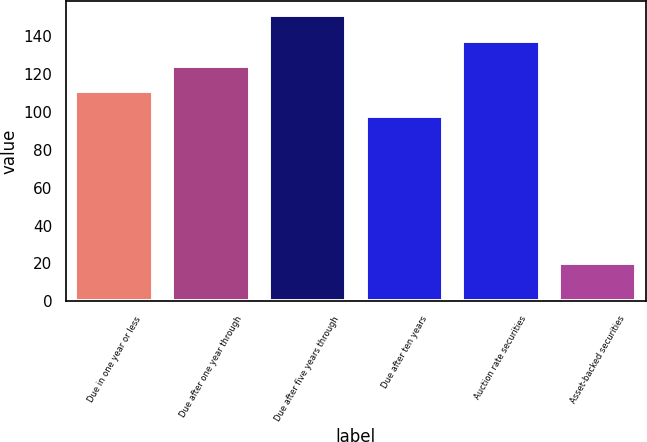<chart> <loc_0><loc_0><loc_500><loc_500><bar_chart><fcel>Due in one year or less<fcel>Due after one year through<fcel>Due after five years through<fcel>Due after ten years<fcel>Auction rate securities<fcel>Asset-backed securities<nl><fcel>111.1<fcel>124.2<fcel>151<fcel>98<fcel>137.3<fcel>20<nl></chart> 